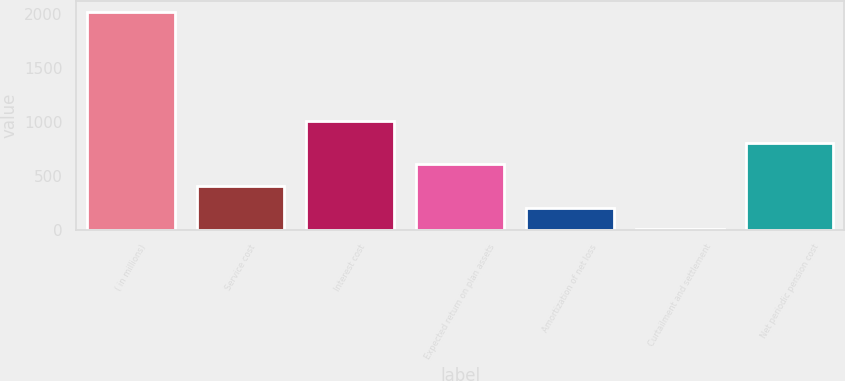Convert chart to OTSL. <chart><loc_0><loc_0><loc_500><loc_500><bar_chart><fcel>( in millions)<fcel>Service cost<fcel>Interest cost<fcel>Expected return on plan assets<fcel>Amortization of net loss<fcel>Curtailment and settlement<fcel>Net periodic pension cost<nl><fcel>2014<fcel>403.36<fcel>1007.35<fcel>604.69<fcel>202.03<fcel>0.7<fcel>806.02<nl></chart> 